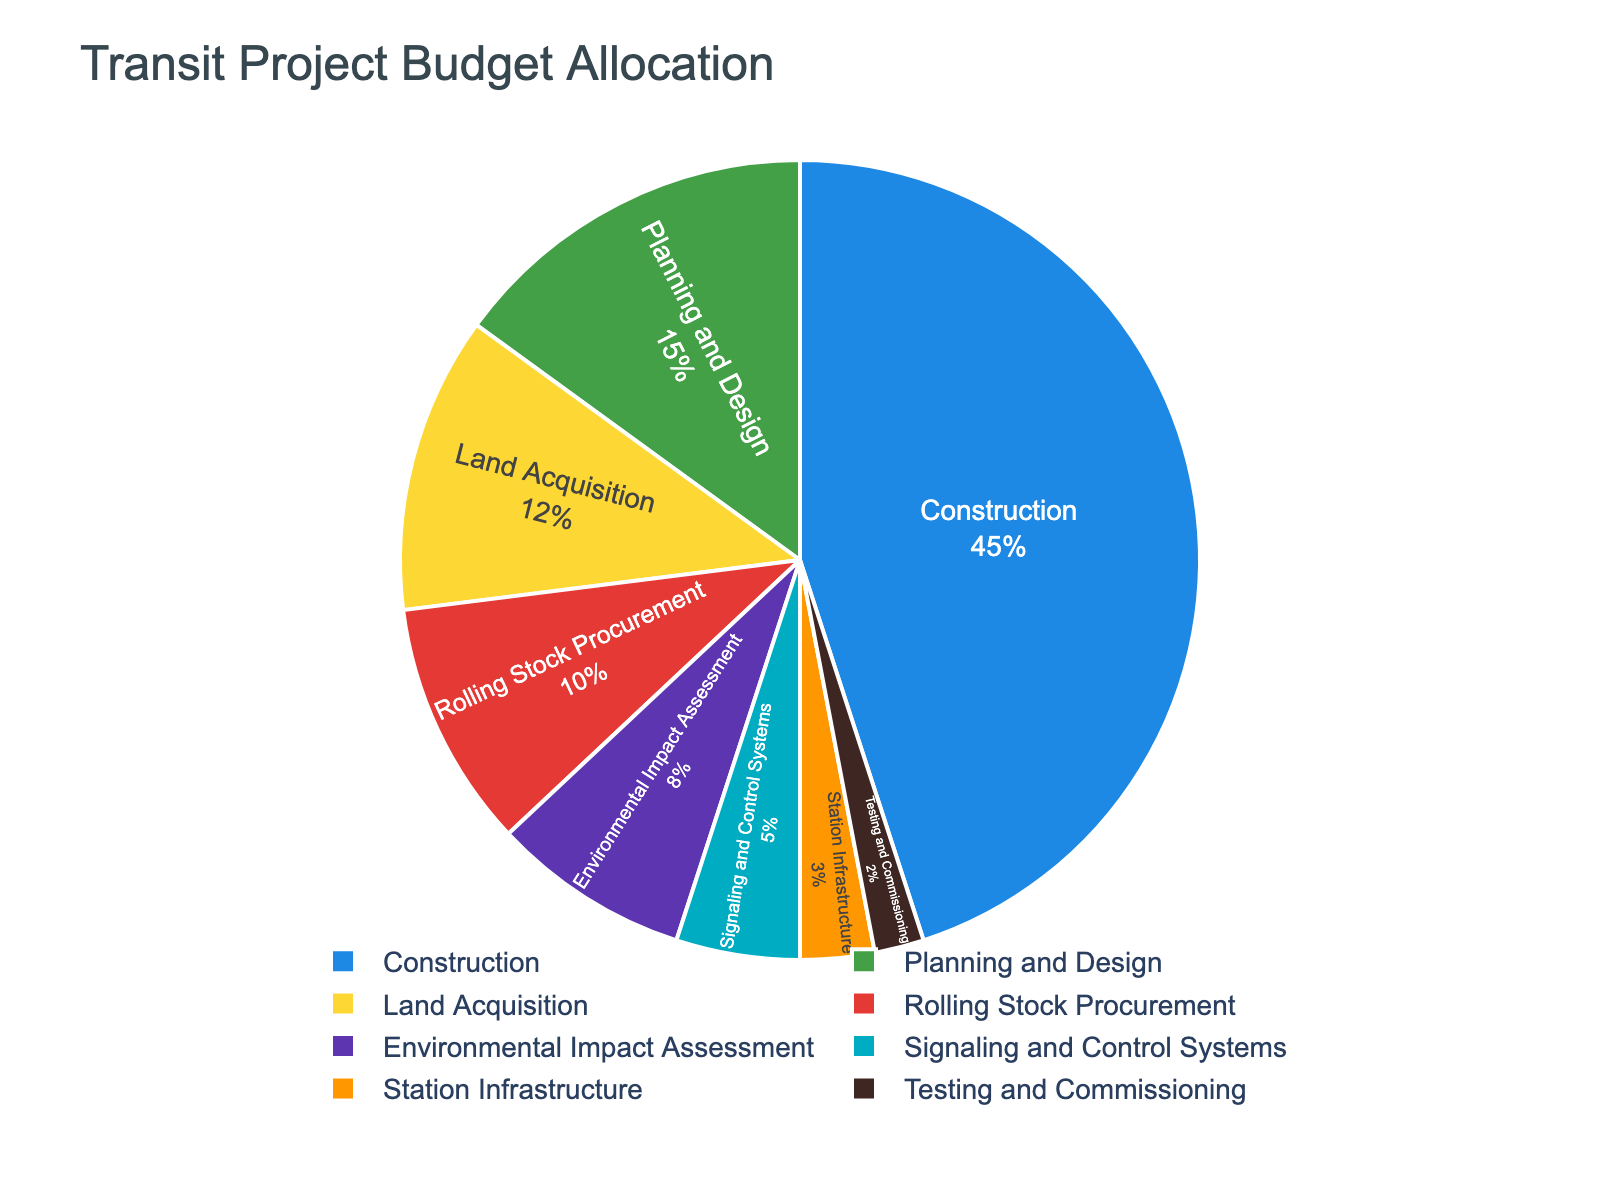Which development phase receives the largest share of the budget? By looking at the pie chart, the segment representing "Construction" is the largest, indicating that it receives the largest share of the budget.
Answer: Construction Which two phases have the smallest and second smallest shares of the budget? By observing the pie chart, the segments for "Testing and Commissioning" and "Station Infrastructure" are the smallest, making them the smallest and second smallest shares, respectively.
Answer: Testing and Commissioning, Station Infrastructure How much budget is allocated to Construction and Land Acquisition combined? From the chart, Construction has a 45% share and Land Acquisition has a 12% share. Adding these two percentages gives 45% + 12% = 57%.
Answer: 57% Which development phase is represented by a green segment in the pie chart? In the legend, the green color corresponds to the "Environmental Impact Assessment" phase.
Answer: Environmental Impact Assessment Is the budget for Rolling Stock Procurement higher or lower than that for Land Acquisition? Comparing their segments in the pie chart, Rolling Stock Procurement has a 10% share while Land Acquisition has a 12% share. Therefore, Rolling Stock Procurement is lower.
Answer: Lower What is the total percentage of the budget allocated to phases related to infrastructure (Land Acquisition + Construction + Station Infrastructure)? Adding the percentages for each relevant phase: Land Acquisition (12%) + Construction (45%) + Station Infrastructure (3%) gives a total of 12% + 45% + 3% = 60%.
Answer: 60% What phases together make up more than half of the budget? By examining the pie chart, Construction (45%) and Land Acquisition (12%) together make 45% + 12% = 57%, which is more than half of the budget.
Answer: Construction, Land Acquisition How does the budget allocated to Signaling and Control Systems compare to the budget for Environmental Impact Assessment? From the pie chart, Signaling and Control Systems have a 5% share while Environmental Impact Assessment has an 8% share. Thus, the budget for Signaling and Control Systems is smaller.
Answer: Smaller What is the combined budget allocation for phases that make up less than 10% each? Adding the budgets for Environmental Impact Assessment (8%), Signaling and Control Systems (5%), Station Infrastructure (3%), and Testing and Commissioning (2%) gives 8% + 5% + 3% + 2% = 18%.
Answer: 18% How many phases have more than a 10% share of the budget allocation? The pie chart shows that Planning and Design (15%), Land Acquisition (12%), Construction (45%), and Rolling Stock Procurement (10%) are above 10%. Hence, there are 4 phases.
Answer: 4 